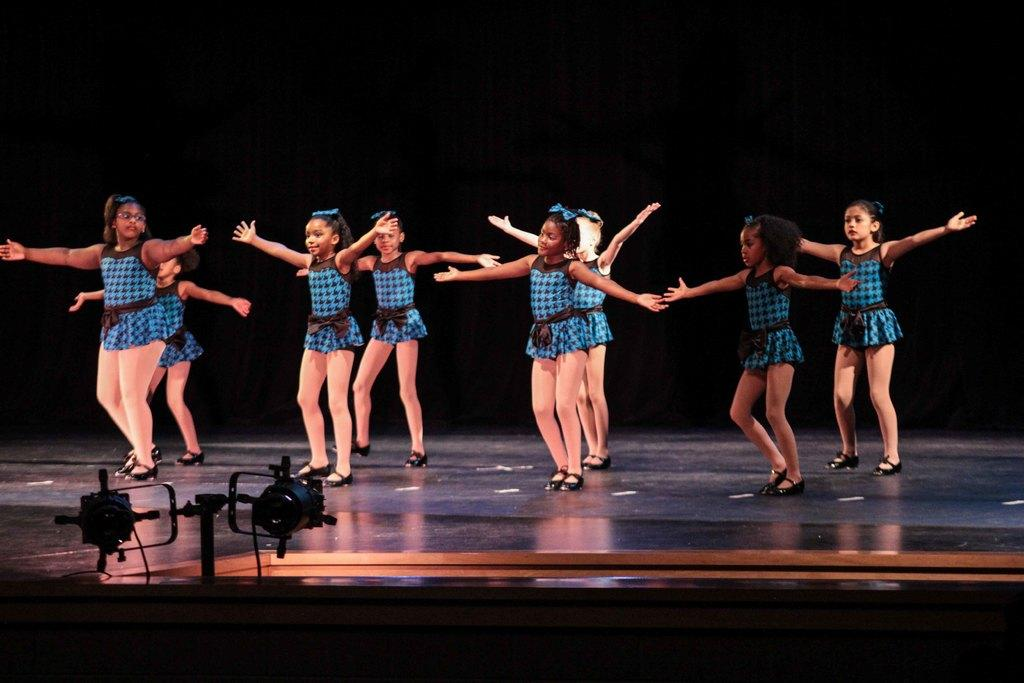What are the people in the image doing? The people are performing dance on the stage. What else can be seen in the image besides the dancers? There are cameras visible in the image. What is in the background of the image? There is a curtain in the background of the image. What color is the crayon being used by the governor in the image? There is no governor or crayon present in the image. 